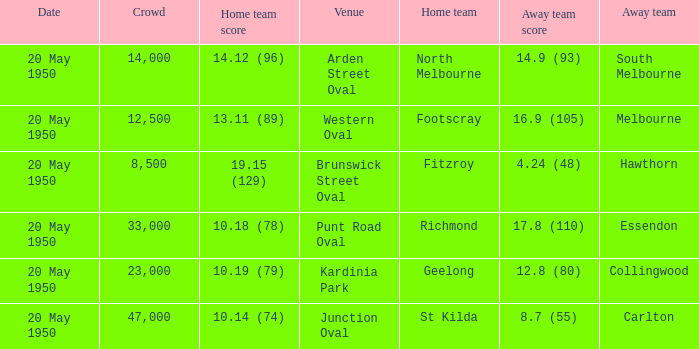What was the date of the game when the away team was south melbourne? 20 May 1950. 